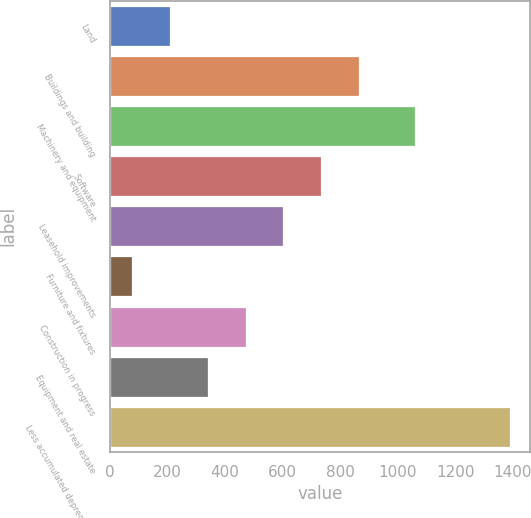<chart> <loc_0><loc_0><loc_500><loc_500><bar_chart><fcel>Land<fcel>Buildings and building<fcel>Machinery and equipment<fcel>Software<fcel>Leasehold improvements<fcel>Furniture and fixtures<fcel>Construction in progress<fcel>Equipment and real estate<fcel>Less accumulated depreciation<nl><fcel>208.42<fcel>866.02<fcel>1060.1<fcel>734.5<fcel>602.98<fcel>76.9<fcel>471.46<fcel>339.94<fcel>1392.1<nl></chart> 